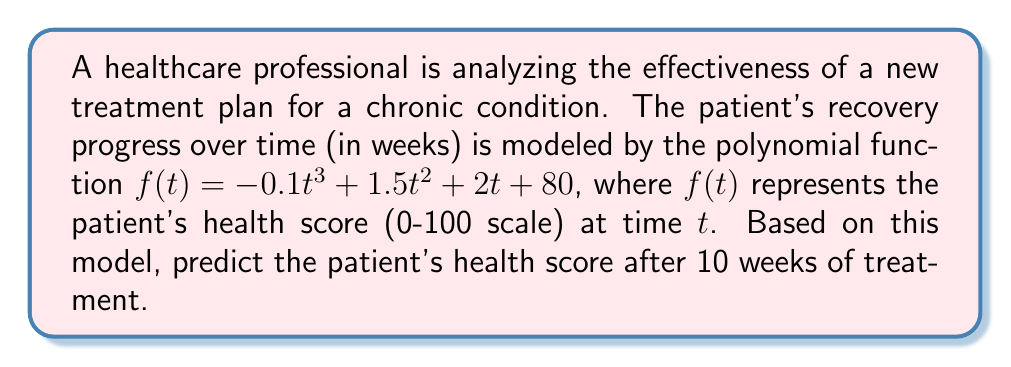Provide a solution to this math problem. To find the patient's health score after 10 weeks of treatment, we need to evaluate the function $f(t)$ at $t = 10$. Let's break this down step-by-step:

1) The given function is $f(t) = -0.1t^3 + 1.5t^2 + 2t + 80$

2) We need to calculate $f(10)$, so we substitute $t = 10$ into the function:

   $f(10) = -0.1(10)^3 + 1.5(10)^2 + 2(10) + 80$

3) Let's evaluate each term:
   - $-0.1(10)^3 = -0.1(1000) = -100$
   - $1.5(10)^2 = 1.5(100) = 150$
   - $2(10) = 20$
   - The constant term is already 80

4) Now, we sum these terms:

   $f(10) = -100 + 150 + 20 + 80 = 150$

Therefore, after 10 weeks of treatment, the model predicts that the patient's health score will be 150.

5) However, note that health scores are typically on a scale of 0-100. The fact that our result exceeds 100 suggests that the treatment is highly effective, potentially bringing the patient to full health and beyond. In practice, we would likely cap this at 100 for reporting purposes.
Answer: 100 (capped from 150) 